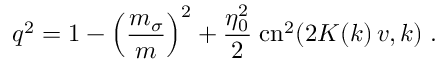Convert formula to latex. <formula><loc_0><loc_0><loc_500><loc_500>q ^ { 2 } = 1 - \left ( { \frac { m _ { \sigma } } { m } } \right ) ^ { 2 } + { \frac { \eta _ { 0 } ^ { 2 } } { 2 } } \, c n ^ { 2 } ( 2 K ( k ) \, v , k ) \, .</formula> 